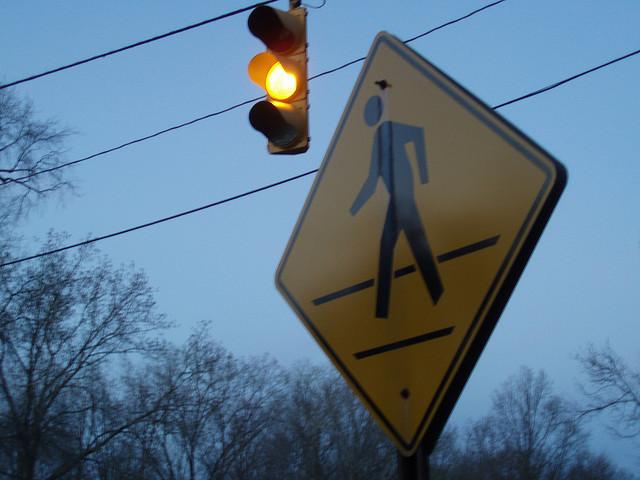Can you cross the street now?
Write a very short answer. No. What color is the sign?
Answer briefly. Yellow. Was this photo taken in the summer?
Be succinct. No. What is the yellow object?
Keep it brief. Sign. 